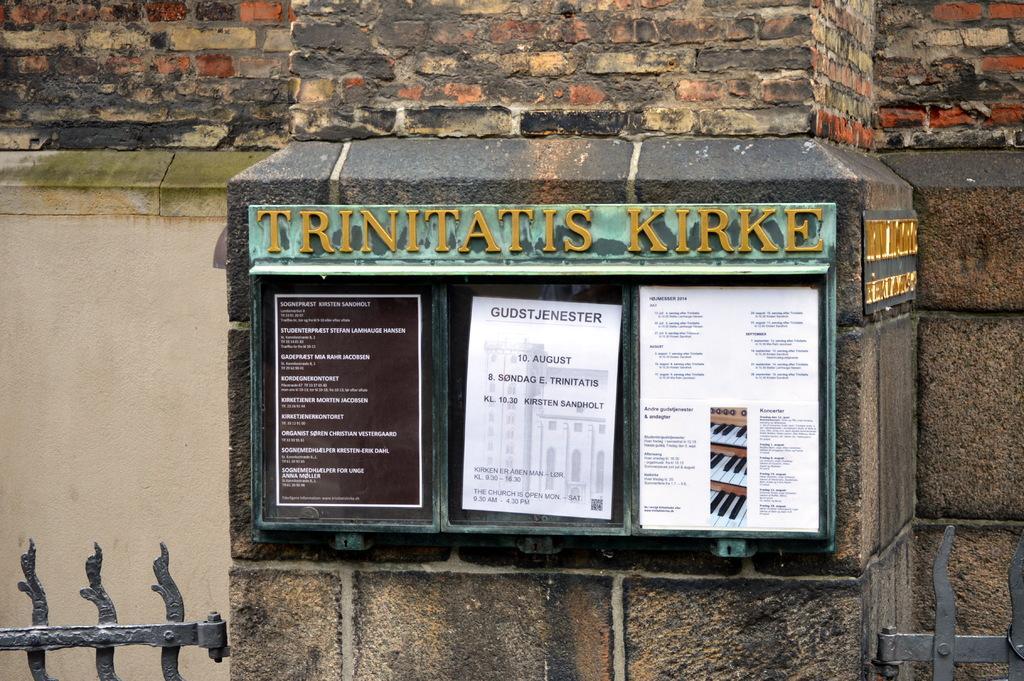Please provide a concise description of this image. In the middle of the image there is a pillar with notice board with few posters in it. Above that there is a name board. To the left bottom there is a gate and to the right bottom there is a gate. To the top of the image there is a brick wall. 